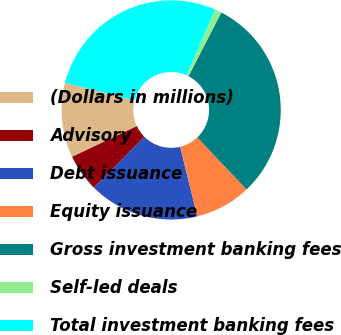Convert chart. <chart><loc_0><loc_0><loc_500><loc_500><pie_chart><fcel>(Dollars in millions)<fcel>Advisory<fcel>Debt issuance<fcel>Equity issuance<fcel>Gross investment banking fees<fcel>Self-led deals<fcel>Total investment banking fees<nl><fcel>11.01%<fcel>5.49%<fcel>16.3%<fcel>8.25%<fcel>30.36%<fcel>0.98%<fcel>27.6%<nl></chart> 